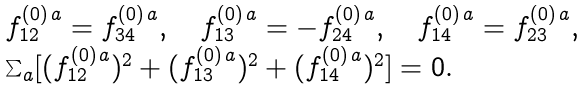Convert formula to latex. <formula><loc_0><loc_0><loc_500><loc_500>\begin{array} { l } { f ^ { ( 0 ) \, a } _ { 1 2 } = f ^ { ( 0 ) \, a } _ { 3 4 } , \quad f ^ { ( 0 ) \, a } _ { 1 3 } = - f ^ { ( 0 ) \, a } _ { 2 4 } , \quad f ^ { ( 0 ) \, a } _ { 1 4 } = f ^ { ( 0 ) \, a } _ { 2 3 } , } \\ \sum _ { a } [ { ( f ^ { ( 0 ) \, a } _ { 1 2 } ) ^ { 2 } + ( f ^ { ( 0 ) \, a } _ { 1 3 } ) ^ { 2 } + ( f ^ { ( 0 ) \, a } _ { 1 4 } ) ^ { 2 } ] = 0 . } \\ \end{array}</formula> 